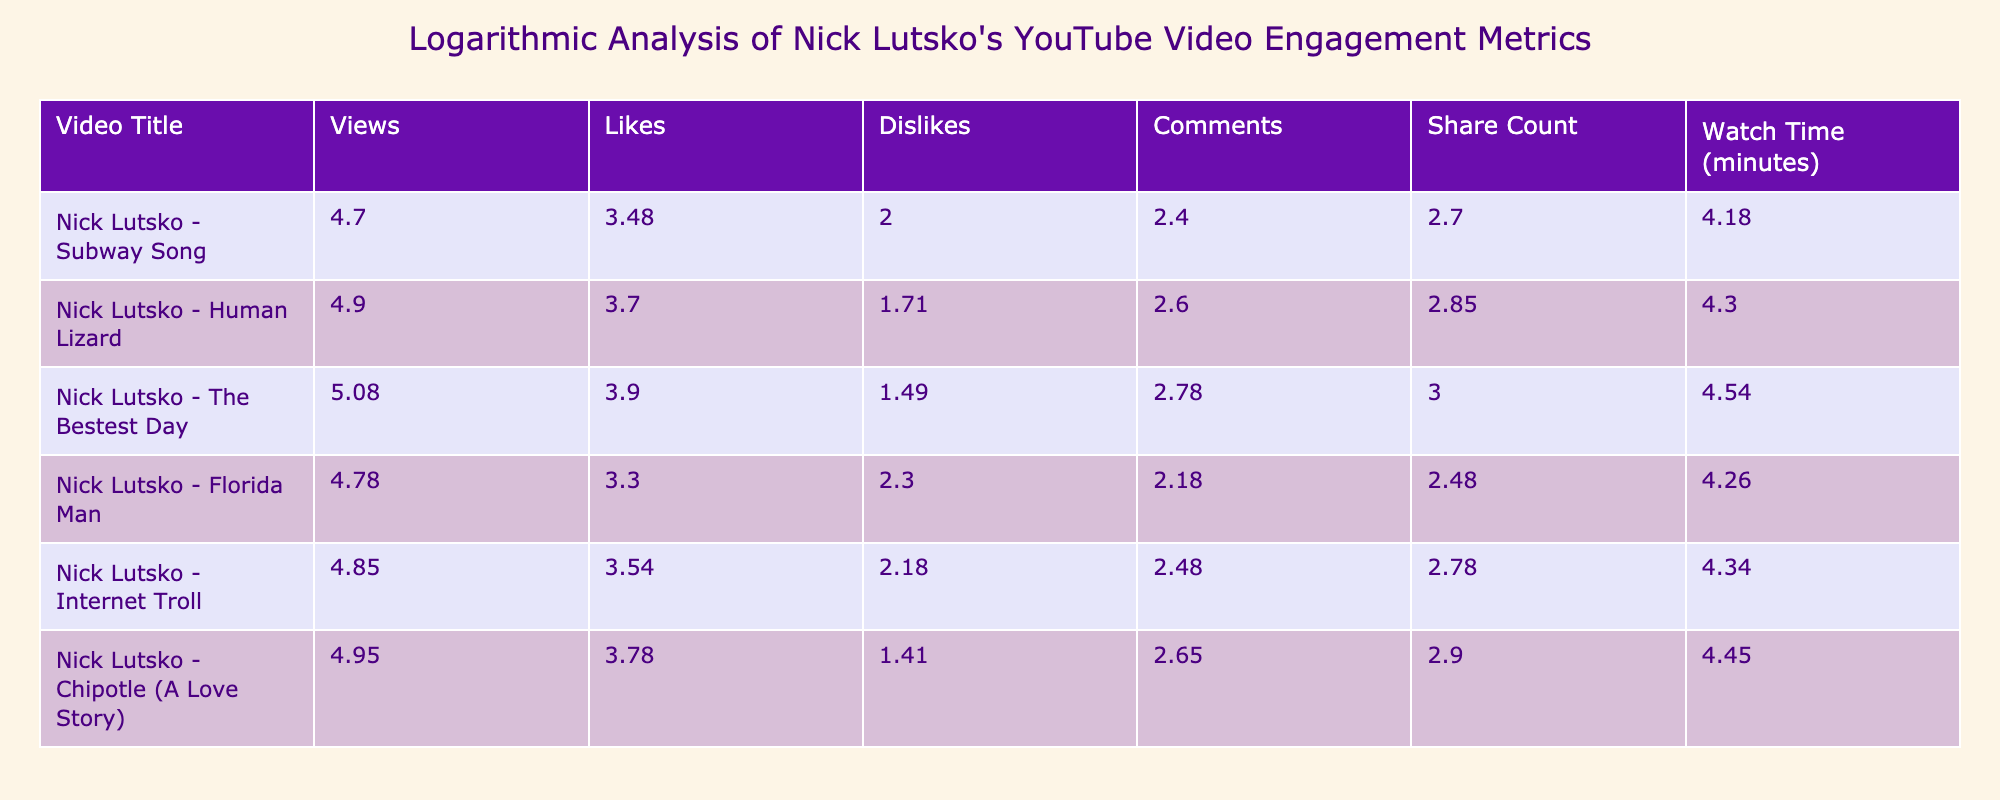What are the views of "Nick Lutsko - The Bestest Day"? The table shows that "Nick Lutsko - The Bestest Day" has 120000 views listed under the Views column.
Answer: 120000 Which video has the highest number of likes? From the Likes column, "Nick Lutsko - The Bestest Day" has the highest number of likes, totaling 8000.
Answer: 8000 What is the difference in watch time between "Nick Lutsko - Subway Song" and "Nick Lutsko - Florida Man"? The watch time for "Nick Lutsko - Subway Song" is 15000 minutes and for "Nick Lutsko - Florida Man" is 18000 minutes. The difference is 18000 - 15000 = 3000 minutes.
Answer: 3000 Is there a video with more dislikes than "Nick Lutsko - Chipotle (A Love Story)"? "Nick Lutsko - Chipotle (A Love Story)" has 25 dislikes, and upon checking the Dislikes column, the video "Nick Lutsko - Florida Man" has 200 dislikes, which is higher.
Answer: Yes Calculate the average number of views for all videos listed. To find the average, sum all the views: 50000 + 80000 + 120000 + 60000 + 70000 + 90000 = 490000. There are 6 videos, so the average is 490000 / 6 = 81666.67.
Answer: 81666.67 Which video has the least number of comments and how many? In the Comments column, "Nick Lutsko - Subway Song" has 250 comments, which is the least compared to other videos.
Answer: 250 How many total shares were there across all videos? The total shares can be calculated by adding all share counts: 500 + 700 + 1000 + 300 + 600 + 800. This sums to 3900 shares for all videos.
Answer: 3900 Is it true that "Nick Lutsko - Human Lizard" has more comments than "Nick Lutsko - Internet Troll"? "Nick Lutsko - Human Lizard" has 400 comments while "Nick Lutsko - Internet Troll" has 300 comments, so it is true that it has more comments.
Answer: Yes What is the logarithmic scale value of likes for "Nick Lutsko - Florida Man"? To find the logarithmic value of likes for "Nick Lutsko - Florida Man" (which has 2000 likes), we compute log10(2000 + 1). The result rounds to approximately 3.30.
Answer: 3.30 